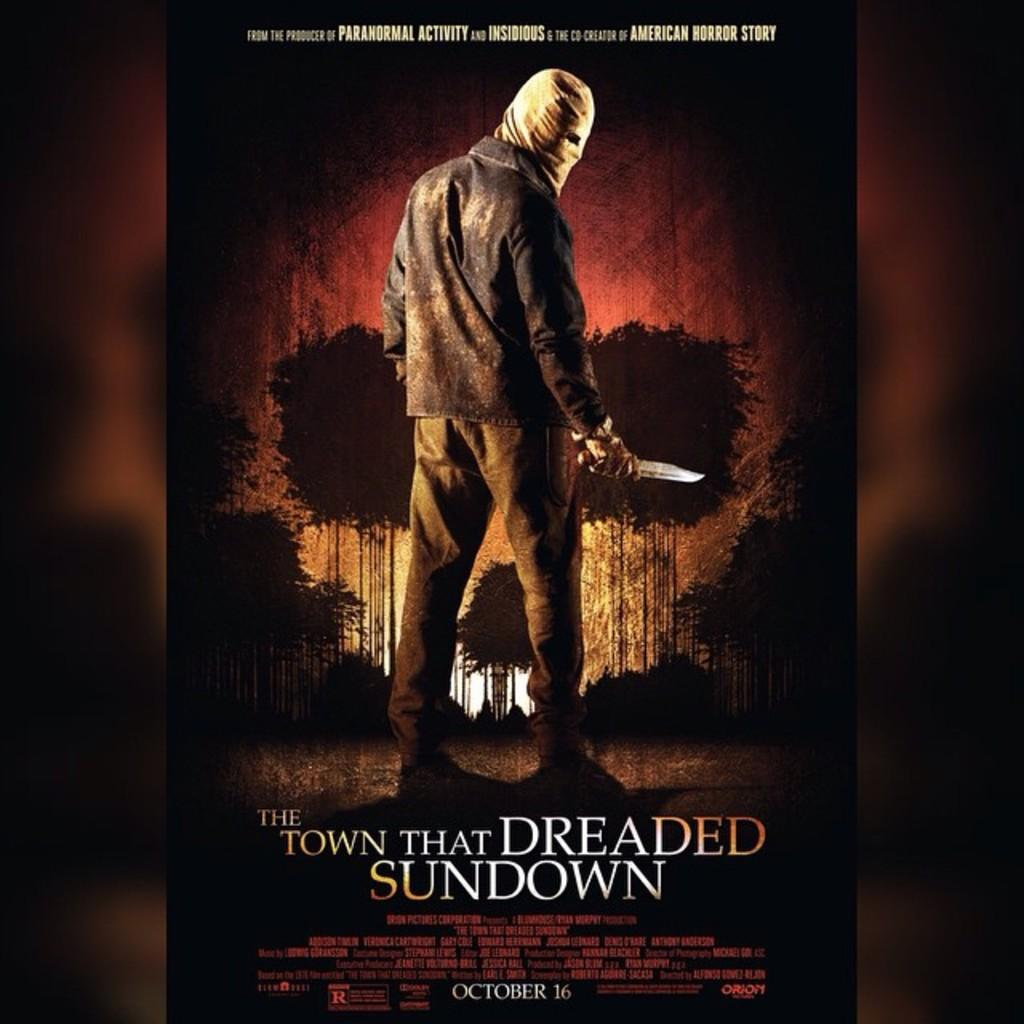Provide a one-sentence caption for the provided image. A movie poster of The Town that Dreaded Sundown. 